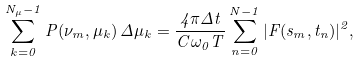<formula> <loc_0><loc_0><loc_500><loc_500>\sum _ { k = 0 } ^ { N _ { \mu } - 1 } P ( \nu _ { m } , \mu _ { k } ) \, \Delta \mu _ { k } = \frac { 4 \pi \Delta t } { C \omega _ { 0 } T } \sum _ { n = 0 } ^ { N - 1 } | F ( s _ { m } , t _ { n } ) | ^ { 2 } ,</formula> 